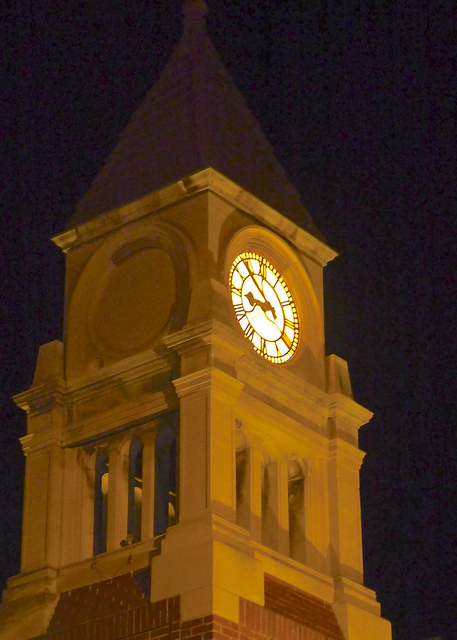Read and extract the text from this image. XII XI 